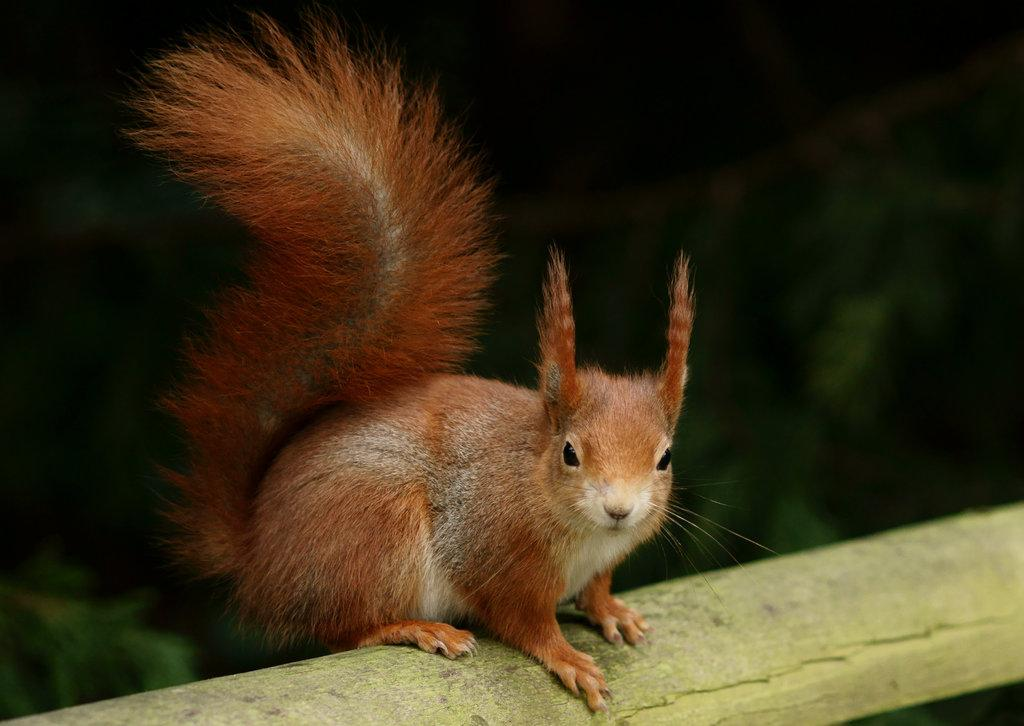What animal can be seen in the image? There is a squirrel in the image. Can you describe the background of the image? The background of the image is blurry. What year is the squirrel celebrating in the image? There is no indication of a specific year or celebration in the image; it simply features a squirrel. 